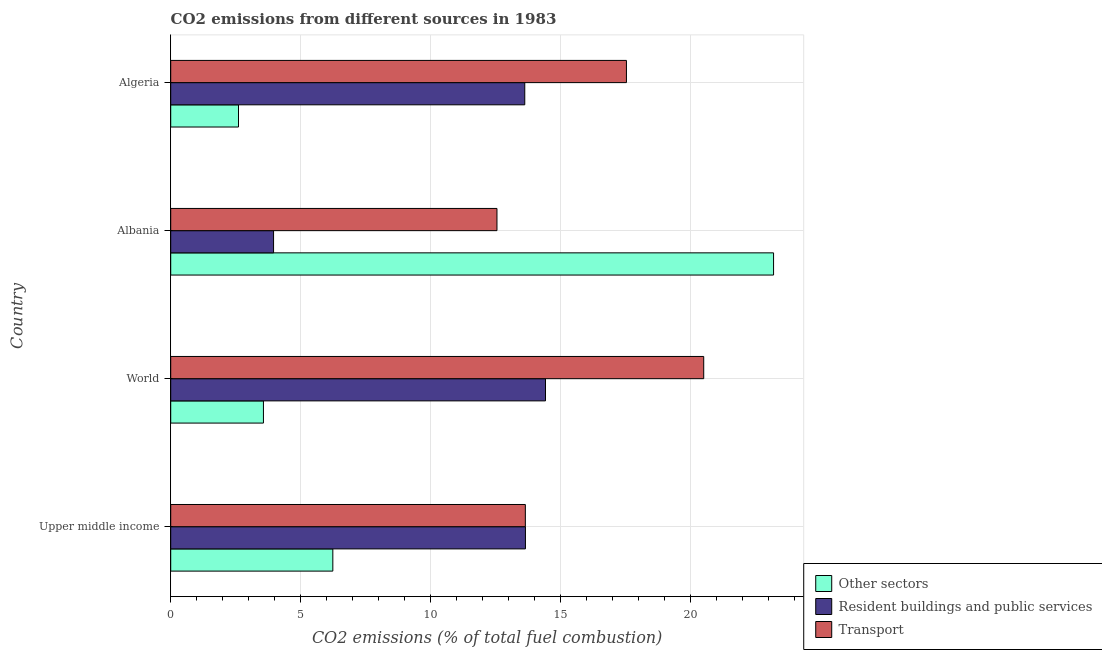How many different coloured bars are there?
Give a very brief answer. 3. How many groups of bars are there?
Offer a terse response. 4. Are the number of bars per tick equal to the number of legend labels?
Keep it short and to the point. Yes. How many bars are there on the 3rd tick from the top?
Your answer should be very brief. 3. How many bars are there on the 3rd tick from the bottom?
Your response must be concise. 3. What is the label of the 4th group of bars from the top?
Give a very brief answer. Upper middle income. What is the percentage of co2 emissions from transport in Albania?
Offer a very short reply. 12.55. Across all countries, what is the maximum percentage of co2 emissions from transport?
Your response must be concise. 20.51. Across all countries, what is the minimum percentage of co2 emissions from resident buildings and public services?
Offer a very short reply. 3.96. In which country was the percentage of co2 emissions from other sectors minimum?
Provide a succinct answer. Algeria. What is the total percentage of co2 emissions from other sectors in the graph?
Make the answer very short. 35.6. What is the difference between the percentage of co2 emissions from other sectors in Albania and that in World?
Make the answer very short. 19.63. What is the difference between the percentage of co2 emissions from transport in World and the percentage of co2 emissions from other sectors in Albania?
Offer a very short reply. -2.69. What is the average percentage of co2 emissions from transport per country?
Provide a short and direct response. 16.06. What is the difference between the percentage of co2 emissions from resident buildings and public services and percentage of co2 emissions from other sectors in Albania?
Offer a terse response. -19.24. What is the ratio of the percentage of co2 emissions from resident buildings and public services in Albania to that in Algeria?
Ensure brevity in your answer.  0.29. Is the percentage of co2 emissions from resident buildings and public services in Algeria less than that in Upper middle income?
Your response must be concise. Yes. Is the difference between the percentage of co2 emissions from resident buildings and public services in Albania and Algeria greater than the difference between the percentage of co2 emissions from transport in Albania and Algeria?
Offer a very short reply. No. What is the difference between the highest and the second highest percentage of co2 emissions from resident buildings and public services?
Offer a very short reply. 0.77. What is the difference between the highest and the lowest percentage of co2 emissions from resident buildings and public services?
Give a very brief answer. 10.46. In how many countries, is the percentage of co2 emissions from resident buildings and public services greater than the average percentage of co2 emissions from resident buildings and public services taken over all countries?
Offer a very short reply. 3. Is the sum of the percentage of co2 emissions from resident buildings and public services in Albania and Algeria greater than the maximum percentage of co2 emissions from other sectors across all countries?
Your response must be concise. No. What does the 3rd bar from the top in Algeria represents?
Offer a terse response. Other sectors. What does the 1st bar from the bottom in Algeria represents?
Offer a very short reply. Other sectors. Is it the case that in every country, the sum of the percentage of co2 emissions from other sectors and percentage of co2 emissions from resident buildings and public services is greater than the percentage of co2 emissions from transport?
Ensure brevity in your answer.  No. Are all the bars in the graph horizontal?
Provide a succinct answer. Yes. How many countries are there in the graph?
Keep it short and to the point. 4. Does the graph contain any zero values?
Offer a terse response. No. Does the graph contain grids?
Your response must be concise. Yes. Where does the legend appear in the graph?
Give a very brief answer. Bottom right. How many legend labels are there?
Ensure brevity in your answer.  3. How are the legend labels stacked?
Provide a succinct answer. Vertical. What is the title of the graph?
Your answer should be compact. CO2 emissions from different sources in 1983. Does "Transport" appear as one of the legend labels in the graph?
Provide a short and direct response. Yes. What is the label or title of the X-axis?
Provide a succinct answer. CO2 emissions (% of total fuel combustion). What is the label or title of the Y-axis?
Give a very brief answer. Country. What is the CO2 emissions (% of total fuel combustion) in Other sectors in Upper middle income?
Give a very brief answer. 6.24. What is the CO2 emissions (% of total fuel combustion) of Resident buildings and public services in Upper middle income?
Give a very brief answer. 13.65. What is the CO2 emissions (% of total fuel combustion) of Transport in Upper middle income?
Your answer should be very brief. 13.64. What is the CO2 emissions (% of total fuel combustion) of Other sectors in World?
Keep it short and to the point. 3.57. What is the CO2 emissions (% of total fuel combustion) in Resident buildings and public services in World?
Offer a very short reply. 14.42. What is the CO2 emissions (% of total fuel combustion) of Transport in World?
Provide a short and direct response. 20.51. What is the CO2 emissions (% of total fuel combustion) of Other sectors in Albania?
Your response must be concise. 23.19. What is the CO2 emissions (% of total fuel combustion) in Resident buildings and public services in Albania?
Make the answer very short. 3.96. What is the CO2 emissions (% of total fuel combustion) in Transport in Albania?
Offer a terse response. 12.55. What is the CO2 emissions (% of total fuel combustion) of Other sectors in Algeria?
Offer a terse response. 2.61. What is the CO2 emissions (% of total fuel combustion) of Resident buildings and public services in Algeria?
Your response must be concise. 13.62. What is the CO2 emissions (% of total fuel combustion) in Transport in Algeria?
Give a very brief answer. 17.53. Across all countries, what is the maximum CO2 emissions (% of total fuel combustion) in Other sectors?
Your answer should be very brief. 23.19. Across all countries, what is the maximum CO2 emissions (% of total fuel combustion) of Resident buildings and public services?
Provide a succinct answer. 14.42. Across all countries, what is the maximum CO2 emissions (% of total fuel combustion) in Transport?
Give a very brief answer. 20.51. Across all countries, what is the minimum CO2 emissions (% of total fuel combustion) of Other sectors?
Offer a terse response. 2.61. Across all countries, what is the minimum CO2 emissions (% of total fuel combustion) in Resident buildings and public services?
Offer a terse response. 3.96. Across all countries, what is the minimum CO2 emissions (% of total fuel combustion) in Transport?
Keep it short and to the point. 12.55. What is the total CO2 emissions (% of total fuel combustion) of Other sectors in the graph?
Keep it short and to the point. 35.6. What is the total CO2 emissions (% of total fuel combustion) of Resident buildings and public services in the graph?
Give a very brief answer. 45.64. What is the total CO2 emissions (% of total fuel combustion) in Transport in the graph?
Offer a very short reply. 64.23. What is the difference between the CO2 emissions (% of total fuel combustion) of Other sectors in Upper middle income and that in World?
Provide a succinct answer. 2.67. What is the difference between the CO2 emissions (% of total fuel combustion) in Resident buildings and public services in Upper middle income and that in World?
Give a very brief answer. -0.77. What is the difference between the CO2 emissions (% of total fuel combustion) of Transport in Upper middle income and that in World?
Offer a terse response. -6.86. What is the difference between the CO2 emissions (% of total fuel combustion) in Other sectors in Upper middle income and that in Albania?
Provide a short and direct response. -16.96. What is the difference between the CO2 emissions (% of total fuel combustion) of Resident buildings and public services in Upper middle income and that in Albania?
Keep it short and to the point. 9.69. What is the difference between the CO2 emissions (% of total fuel combustion) in Transport in Upper middle income and that in Albania?
Your answer should be compact. 1.09. What is the difference between the CO2 emissions (% of total fuel combustion) in Other sectors in Upper middle income and that in Algeria?
Offer a very short reply. 3.63. What is the difference between the CO2 emissions (% of total fuel combustion) of Resident buildings and public services in Upper middle income and that in Algeria?
Ensure brevity in your answer.  0.03. What is the difference between the CO2 emissions (% of total fuel combustion) of Transport in Upper middle income and that in Algeria?
Your response must be concise. -3.89. What is the difference between the CO2 emissions (% of total fuel combustion) of Other sectors in World and that in Albania?
Offer a very short reply. -19.63. What is the difference between the CO2 emissions (% of total fuel combustion) of Resident buildings and public services in World and that in Albania?
Provide a succinct answer. 10.46. What is the difference between the CO2 emissions (% of total fuel combustion) of Transport in World and that in Albania?
Offer a very short reply. 7.95. What is the difference between the CO2 emissions (% of total fuel combustion) in Other sectors in World and that in Algeria?
Keep it short and to the point. 0.96. What is the difference between the CO2 emissions (% of total fuel combustion) of Resident buildings and public services in World and that in Algeria?
Provide a succinct answer. 0.8. What is the difference between the CO2 emissions (% of total fuel combustion) in Transport in World and that in Algeria?
Give a very brief answer. 2.97. What is the difference between the CO2 emissions (% of total fuel combustion) of Other sectors in Albania and that in Algeria?
Give a very brief answer. 20.58. What is the difference between the CO2 emissions (% of total fuel combustion) in Resident buildings and public services in Albania and that in Algeria?
Keep it short and to the point. -9.66. What is the difference between the CO2 emissions (% of total fuel combustion) of Transport in Albania and that in Algeria?
Your response must be concise. -4.98. What is the difference between the CO2 emissions (% of total fuel combustion) in Other sectors in Upper middle income and the CO2 emissions (% of total fuel combustion) in Resident buildings and public services in World?
Keep it short and to the point. -8.18. What is the difference between the CO2 emissions (% of total fuel combustion) of Other sectors in Upper middle income and the CO2 emissions (% of total fuel combustion) of Transport in World?
Offer a terse response. -14.27. What is the difference between the CO2 emissions (% of total fuel combustion) in Resident buildings and public services in Upper middle income and the CO2 emissions (% of total fuel combustion) in Transport in World?
Your response must be concise. -6.86. What is the difference between the CO2 emissions (% of total fuel combustion) of Other sectors in Upper middle income and the CO2 emissions (% of total fuel combustion) of Resident buildings and public services in Albania?
Offer a terse response. 2.28. What is the difference between the CO2 emissions (% of total fuel combustion) in Other sectors in Upper middle income and the CO2 emissions (% of total fuel combustion) in Transport in Albania?
Provide a succinct answer. -6.31. What is the difference between the CO2 emissions (% of total fuel combustion) of Resident buildings and public services in Upper middle income and the CO2 emissions (% of total fuel combustion) of Transport in Albania?
Offer a terse response. 1.1. What is the difference between the CO2 emissions (% of total fuel combustion) in Other sectors in Upper middle income and the CO2 emissions (% of total fuel combustion) in Resident buildings and public services in Algeria?
Offer a very short reply. -7.38. What is the difference between the CO2 emissions (% of total fuel combustion) in Other sectors in Upper middle income and the CO2 emissions (% of total fuel combustion) in Transport in Algeria?
Provide a short and direct response. -11.3. What is the difference between the CO2 emissions (% of total fuel combustion) of Resident buildings and public services in Upper middle income and the CO2 emissions (% of total fuel combustion) of Transport in Algeria?
Offer a very short reply. -3.89. What is the difference between the CO2 emissions (% of total fuel combustion) in Other sectors in World and the CO2 emissions (% of total fuel combustion) in Resident buildings and public services in Albania?
Provide a short and direct response. -0.39. What is the difference between the CO2 emissions (% of total fuel combustion) of Other sectors in World and the CO2 emissions (% of total fuel combustion) of Transport in Albania?
Offer a terse response. -8.98. What is the difference between the CO2 emissions (% of total fuel combustion) in Resident buildings and public services in World and the CO2 emissions (% of total fuel combustion) in Transport in Albania?
Give a very brief answer. 1.87. What is the difference between the CO2 emissions (% of total fuel combustion) of Other sectors in World and the CO2 emissions (% of total fuel combustion) of Resident buildings and public services in Algeria?
Ensure brevity in your answer.  -10.05. What is the difference between the CO2 emissions (% of total fuel combustion) in Other sectors in World and the CO2 emissions (% of total fuel combustion) in Transport in Algeria?
Give a very brief answer. -13.97. What is the difference between the CO2 emissions (% of total fuel combustion) of Resident buildings and public services in World and the CO2 emissions (% of total fuel combustion) of Transport in Algeria?
Your response must be concise. -3.11. What is the difference between the CO2 emissions (% of total fuel combustion) of Other sectors in Albania and the CO2 emissions (% of total fuel combustion) of Resident buildings and public services in Algeria?
Provide a succinct answer. 9.57. What is the difference between the CO2 emissions (% of total fuel combustion) of Other sectors in Albania and the CO2 emissions (% of total fuel combustion) of Transport in Algeria?
Provide a short and direct response. 5.66. What is the difference between the CO2 emissions (% of total fuel combustion) in Resident buildings and public services in Albania and the CO2 emissions (% of total fuel combustion) in Transport in Algeria?
Make the answer very short. -13.58. What is the average CO2 emissions (% of total fuel combustion) of Other sectors per country?
Make the answer very short. 8.9. What is the average CO2 emissions (% of total fuel combustion) in Resident buildings and public services per country?
Provide a succinct answer. 11.41. What is the average CO2 emissions (% of total fuel combustion) of Transport per country?
Offer a terse response. 16.06. What is the difference between the CO2 emissions (% of total fuel combustion) of Other sectors and CO2 emissions (% of total fuel combustion) of Resident buildings and public services in Upper middle income?
Keep it short and to the point. -7.41. What is the difference between the CO2 emissions (% of total fuel combustion) of Other sectors and CO2 emissions (% of total fuel combustion) of Transport in Upper middle income?
Provide a short and direct response. -7.41. What is the difference between the CO2 emissions (% of total fuel combustion) of Resident buildings and public services and CO2 emissions (% of total fuel combustion) of Transport in Upper middle income?
Keep it short and to the point. 0. What is the difference between the CO2 emissions (% of total fuel combustion) in Other sectors and CO2 emissions (% of total fuel combustion) in Resident buildings and public services in World?
Provide a succinct answer. -10.85. What is the difference between the CO2 emissions (% of total fuel combustion) in Other sectors and CO2 emissions (% of total fuel combustion) in Transport in World?
Offer a terse response. -16.94. What is the difference between the CO2 emissions (% of total fuel combustion) of Resident buildings and public services and CO2 emissions (% of total fuel combustion) of Transport in World?
Your answer should be very brief. -6.09. What is the difference between the CO2 emissions (% of total fuel combustion) in Other sectors and CO2 emissions (% of total fuel combustion) in Resident buildings and public services in Albania?
Give a very brief answer. 19.24. What is the difference between the CO2 emissions (% of total fuel combustion) in Other sectors and CO2 emissions (% of total fuel combustion) in Transport in Albania?
Keep it short and to the point. 10.64. What is the difference between the CO2 emissions (% of total fuel combustion) of Resident buildings and public services and CO2 emissions (% of total fuel combustion) of Transport in Albania?
Ensure brevity in your answer.  -8.59. What is the difference between the CO2 emissions (% of total fuel combustion) in Other sectors and CO2 emissions (% of total fuel combustion) in Resident buildings and public services in Algeria?
Offer a terse response. -11.01. What is the difference between the CO2 emissions (% of total fuel combustion) in Other sectors and CO2 emissions (% of total fuel combustion) in Transport in Algeria?
Offer a terse response. -14.92. What is the difference between the CO2 emissions (% of total fuel combustion) of Resident buildings and public services and CO2 emissions (% of total fuel combustion) of Transport in Algeria?
Your answer should be compact. -3.91. What is the ratio of the CO2 emissions (% of total fuel combustion) of Other sectors in Upper middle income to that in World?
Keep it short and to the point. 1.75. What is the ratio of the CO2 emissions (% of total fuel combustion) of Resident buildings and public services in Upper middle income to that in World?
Offer a very short reply. 0.95. What is the ratio of the CO2 emissions (% of total fuel combustion) of Transport in Upper middle income to that in World?
Your answer should be compact. 0.67. What is the ratio of the CO2 emissions (% of total fuel combustion) in Other sectors in Upper middle income to that in Albania?
Your answer should be compact. 0.27. What is the ratio of the CO2 emissions (% of total fuel combustion) in Resident buildings and public services in Upper middle income to that in Albania?
Your answer should be compact. 3.45. What is the ratio of the CO2 emissions (% of total fuel combustion) of Transport in Upper middle income to that in Albania?
Provide a short and direct response. 1.09. What is the ratio of the CO2 emissions (% of total fuel combustion) in Other sectors in Upper middle income to that in Algeria?
Ensure brevity in your answer.  2.39. What is the ratio of the CO2 emissions (% of total fuel combustion) in Resident buildings and public services in Upper middle income to that in Algeria?
Give a very brief answer. 1. What is the ratio of the CO2 emissions (% of total fuel combustion) in Transport in Upper middle income to that in Algeria?
Your answer should be very brief. 0.78. What is the ratio of the CO2 emissions (% of total fuel combustion) in Other sectors in World to that in Albania?
Ensure brevity in your answer.  0.15. What is the ratio of the CO2 emissions (% of total fuel combustion) of Resident buildings and public services in World to that in Albania?
Ensure brevity in your answer.  3.64. What is the ratio of the CO2 emissions (% of total fuel combustion) of Transport in World to that in Albania?
Offer a very short reply. 1.63. What is the ratio of the CO2 emissions (% of total fuel combustion) in Other sectors in World to that in Algeria?
Keep it short and to the point. 1.37. What is the ratio of the CO2 emissions (% of total fuel combustion) in Resident buildings and public services in World to that in Algeria?
Keep it short and to the point. 1.06. What is the ratio of the CO2 emissions (% of total fuel combustion) in Transport in World to that in Algeria?
Keep it short and to the point. 1.17. What is the ratio of the CO2 emissions (% of total fuel combustion) in Other sectors in Albania to that in Algeria?
Your answer should be compact. 8.89. What is the ratio of the CO2 emissions (% of total fuel combustion) in Resident buildings and public services in Albania to that in Algeria?
Provide a short and direct response. 0.29. What is the ratio of the CO2 emissions (% of total fuel combustion) of Transport in Albania to that in Algeria?
Offer a very short reply. 0.72. What is the difference between the highest and the second highest CO2 emissions (% of total fuel combustion) of Other sectors?
Offer a very short reply. 16.96. What is the difference between the highest and the second highest CO2 emissions (% of total fuel combustion) in Resident buildings and public services?
Your answer should be very brief. 0.77. What is the difference between the highest and the second highest CO2 emissions (% of total fuel combustion) in Transport?
Ensure brevity in your answer.  2.97. What is the difference between the highest and the lowest CO2 emissions (% of total fuel combustion) of Other sectors?
Offer a very short reply. 20.58. What is the difference between the highest and the lowest CO2 emissions (% of total fuel combustion) in Resident buildings and public services?
Your answer should be compact. 10.46. What is the difference between the highest and the lowest CO2 emissions (% of total fuel combustion) in Transport?
Your answer should be very brief. 7.95. 